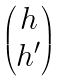Convert formula to latex. <formula><loc_0><loc_0><loc_500><loc_500>\begin{pmatrix} h \\ h ^ { \prime } \end{pmatrix}</formula> 